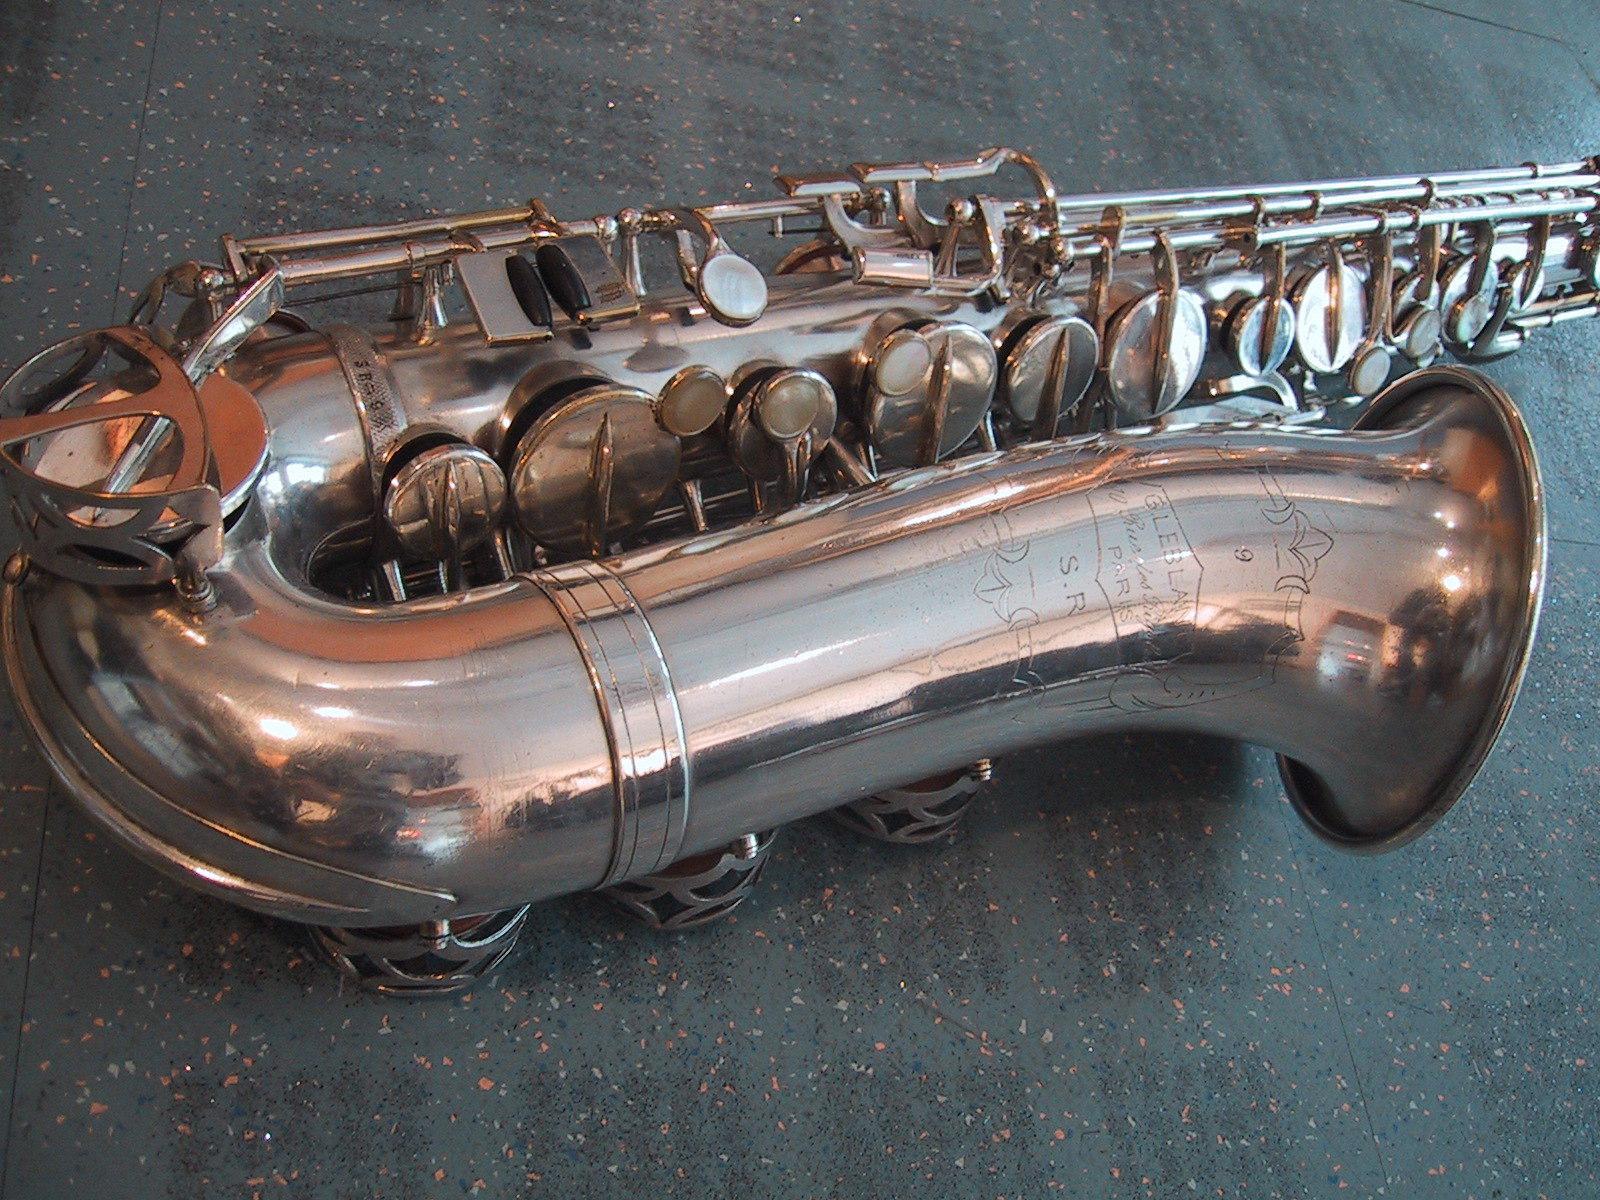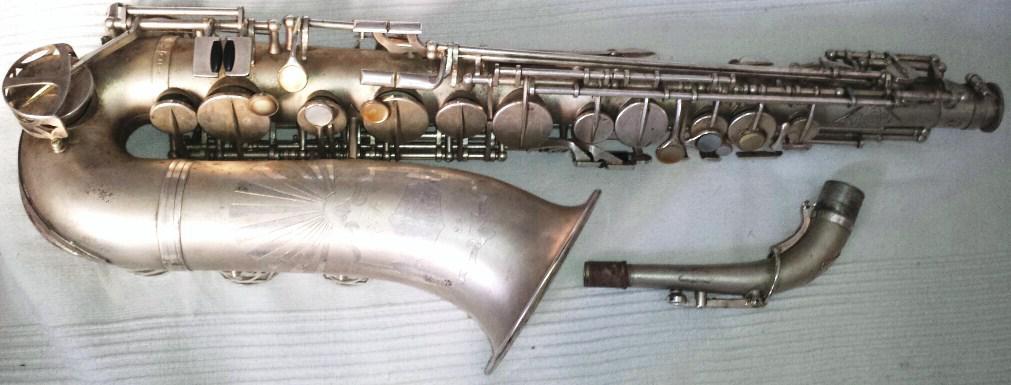The first image is the image on the left, the second image is the image on the right. For the images displayed, is the sentence "One image includes the upturned shiny gold bell of at least one saxophone, and the other image shows the etched surface of a saxophone that is more copper colored." factually correct? Answer yes or no. No. 